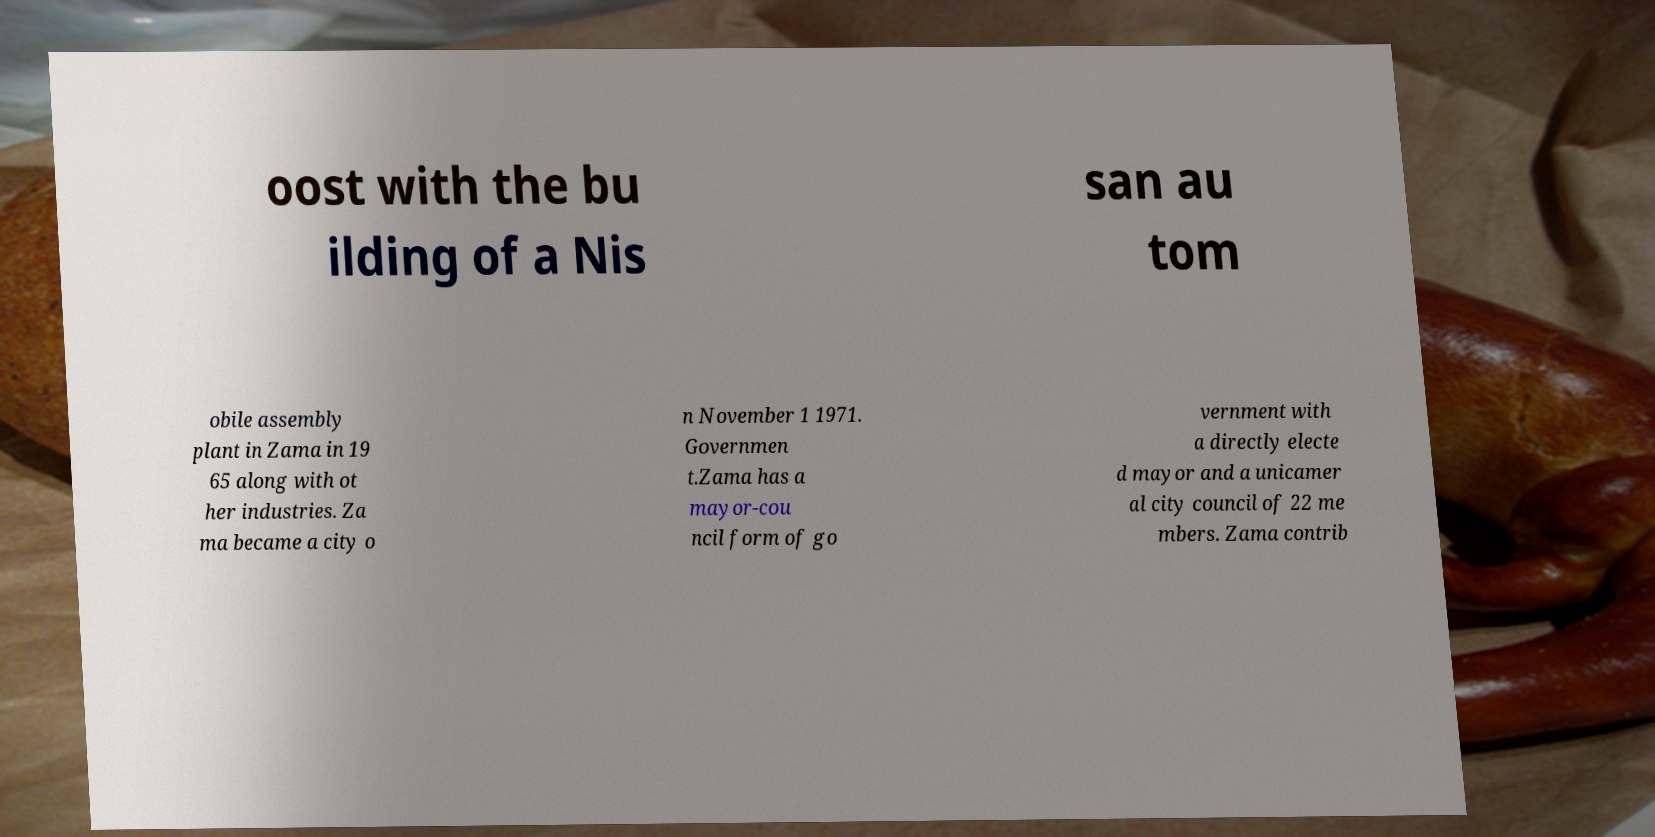Can you read and provide the text displayed in the image?This photo seems to have some interesting text. Can you extract and type it out for me? oost with the bu ilding of a Nis san au tom obile assembly plant in Zama in 19 65 along with ot her industries. Za ma became a city o n November 1 1971. Governmen t.Zama has a mayor-cou ncil form of go vernment with a directly electe d mayor and a unicamer al city council of 22 me mbers. Zama contrib 